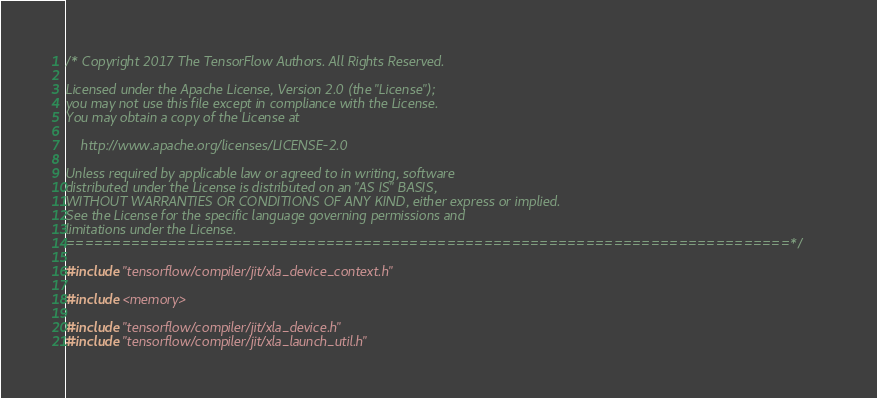Convert code to text. <code><loc_0><loc_0><loc_500><loc_500><_C++_>/* Copyright 2017 The TensorFlow Authors. All Rights Reserved.

Licensed under the Apache License, Version 2.0 (the "License");
you may not use this file except in compliance with the License.
You may obtain a copy of the License at

    http://www.apache.org/licenses/LICENSE-2.0

Unless required by applicable law or agreed to in writing, software
distributed under the License is distributed on an "AS IS" BASIS,
WITHOUT WARRANTIES OR CONDITIONS OF ANY KIND, either express or implied.
See the License for the specific language governing permissions and
limitations under the License.
==============================================================================*/

#include "tensorflow/compiler/jit/xla_device_context.h"

#include <memory>

#include "tensorflow/compiler/jit/xla_device.h"
#include "tensorflow/compiler/jit/xla_launch_util.h"</code> 